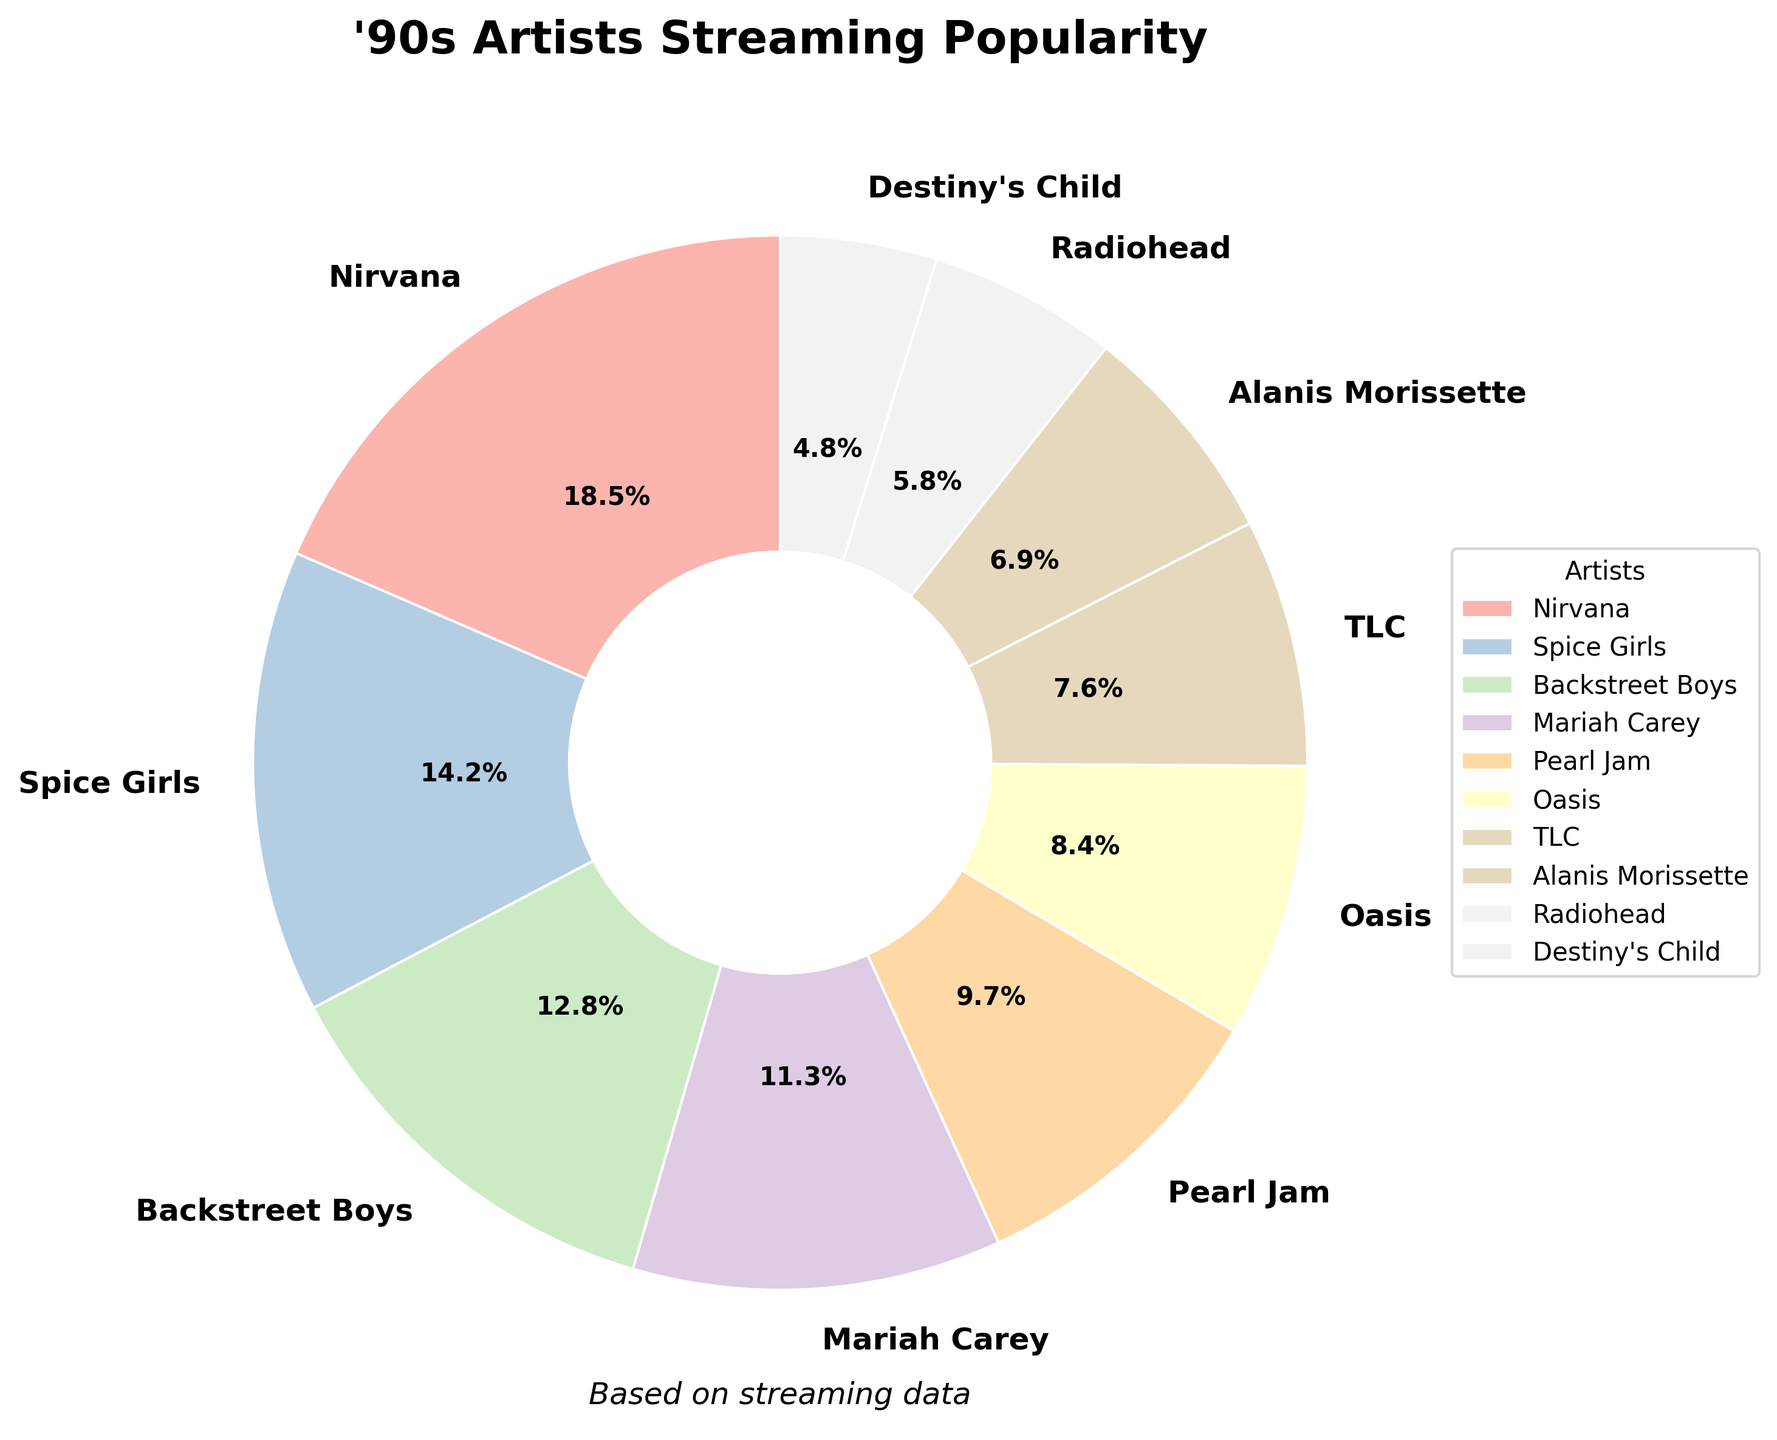Which artist is the most popular according to the streaming data? The pie chart shows the relative streaming percentages for various '90s artists. The artist with the largest segment represents the most popular. Here, Nirvana occupies the largest segment.
Answer: Nirvana Who occupies the smallest portion of the pie chart? Observing the pie chart, the artist with the smallest segment represents the least popular based on streaming percentages. Destiny's Child has the smallest piece of the chart.
Answer: Destiny's Child What is the combined streaming percentage of Nirvana and Spice Girls? According to the chart, Nirvana has 18.5% and Spice Girls have 14.2%. Adding these together: 18.5% + 14.2% = 32.7%.
Answer: 32.7% How does TLC's streaming percentage compare to Backstreet Boys'? The pie chart shows TLC with 7.6% and Backstreet Boys with 12.8%. TLC's percentage is less than Backstreet Boys'.
Answer: Less Which artist has a streaming percentage very close to Radiohead's? From the chart, Radiohead has a streaming percentage of 5.8%. The closest value in the chart is Destiny's Child with 4.8%.
Answer: Destiny's Child What is the average streaming percentage of Pearl Jam, Oasis, and Alanis Morissette? Pearl Jam has 9.7%, Oasis has 8.4%, and Alanis Morissette has 6.9%. The sum of these percentages is 9.7% + 8.4% + 6.9% = 25%. The average is 25% / 3 = 8.33%.
Answer: 8.33% Which two artists have a combined streaming percentage equal to Mariah Carey’s? Mariah Carey has 11.3%. TLC has 7.6% and Radiohead has 5.8%. Adding TLC and Radiohead's percentages: 7.6% + 5.8% = 13.4%, which is not equal. As such, we look at other combinations. Alanis Morissette's 6.9% and Radiohead's 5.8% add up to 12.7%, closest but not equal to Mariah Carey. None other pairs exactly sum up to 11.3%.
Answer: None Identify the artist segment that is visually approximately half of Nirvana's segment. Nirvana’s segment is 18.5%. Half of this value is around 9.25%. Pearl Jam, with 9.7%, is the closest visually to half of Nirvana's portion.
Answer: Pearl Jam What is the sum of the streaming percentages for all artists shown in the chart? Summing all the mentioned streaming percentages: 18.5% (Nirvana) + 14.2% (Spice Girls) + 12.8% (Backstreet Boys) + 11.3% (Mariah Carey) + 9.7% (Pearl Jam) + 8.4% (Oasis) + 7.6% (TLC) + 6.9% (Alanis Morissette) + 5.8% (Radiohead) + 4.8% (Destiny's Child) = 100%.
Answer: 100% What percentage difference is there between the most popular and the least popular artist? Nirvana, the most popular artist, has 18.5%. Destiny’s Child, the least popular, has 4.8%. The percentage difference is calculated as 18.5% - 4.8% = 13.7%.
Answer: 13.7% 